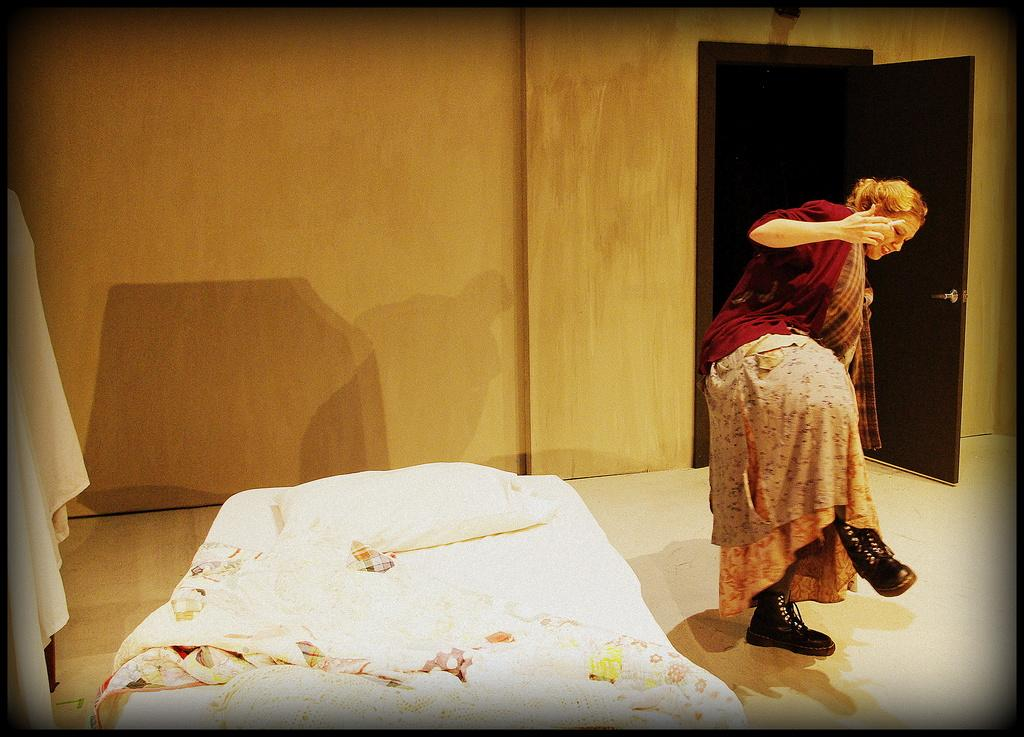What is on the floor in the image? There is a bed on the floor in the image. What is on top of the bed? There is a pillow and a bed-sheet on the bed. Who is present in the image? There is a woman standing in the image. What can be seen in the background of the image? There is a wall and a door in the background. How does the woman in the image react to the approval of her proposal? There is no indication in the image that the woman is reacting to the approval of a proposal, as the image only shows her standing near a bed. What causes the woman to fall in the image? There is no indication in the image that the woman falls, as she is standing upright. 